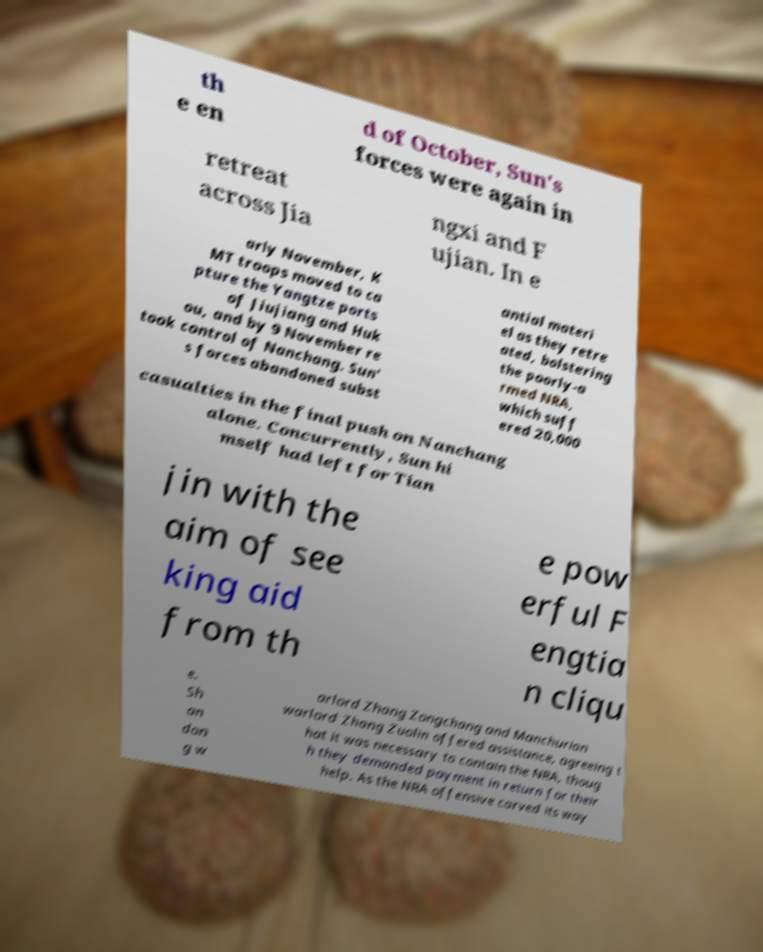Can you accurately transcribe the text from the provided image for me? th e en d of October, Sun's forces were again in retreat across Jia ngxi and F ujian. In e arly November, K MT troops moved to ca pture the Yangtze ports of Jiujiang and Huk ou, and by 9 November re took control of Nanchang. Sun' s forces abandoned subst antial materi el as they retre ated, bolstering the poorly-a rmed NRA, which suff ered 20,000 casualties in the final push on Nanchang alone. Concurrently, Sun hi mself had left for Tian jin with the aim of see king aid from th e pow erful F engtia n cliqu e. Sh an don g w arlord Zhang Zongchang and Manchurian warlord Zhang Zuolin offered assistance, agreeing t hat it was necessary to contain the NRA, thoug h they demanded payment in return for their help. As the NRA offensive carved its way 